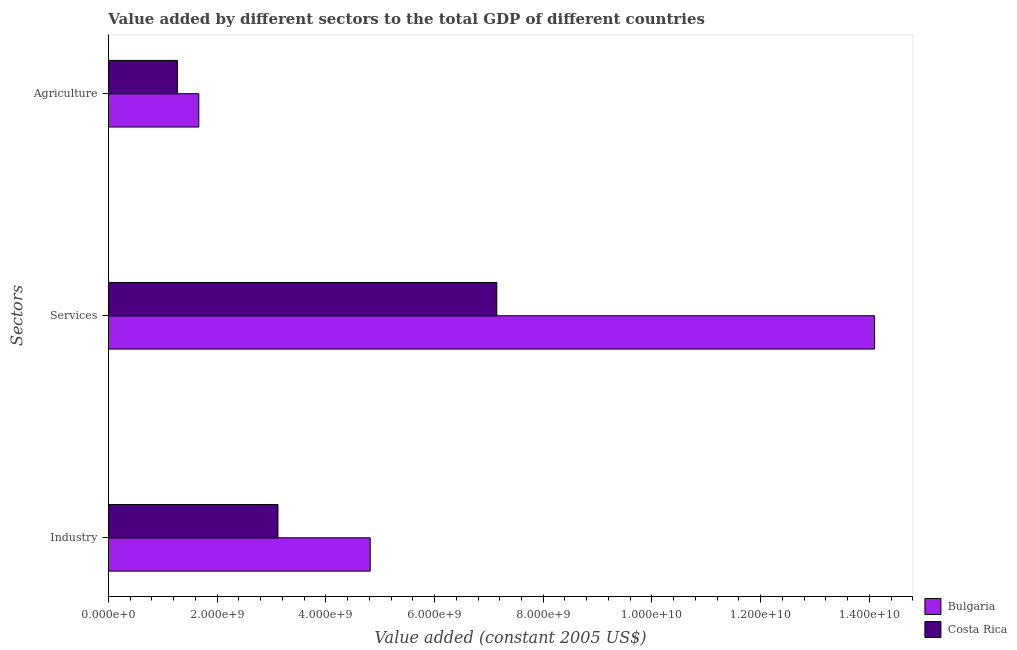How many different coloured bars are there?
Ensure brevity in your answer.  2. How many groups of bars are there?
Offer a very short reply. 3. Are the number of bars on each tick of the Y-axis equal?
Keep it short and to the point. Yes. How many bars are there on the 2nd tick from the top?
Keep it short and to the point. 2. What is the label of the 1st group of bars from the top?
Offer a terse response. Agriculture. What is the value added by agricultural sector in Costa Rica?
Your response must be concise. 1.27e+09. Across all countries, what is the maximum value added by agricultural sector?
Your answer should be compact. 1.66e+09. Across all countries, what is the minimum value added by agricultural sector?
Provide a short and direct response. 1.27e+09. In which country was the value added by services maximum?
Offer a very short reply. Bulgaria. In which country was the value added by services minimum?
Give a very brief answer. Costa Rica. What is the total value added by services in the graph?
Your answer should be compact. 2.12e+1. What is the difference between the value added by industrial sector in Costa Rica and that in Bulgaria?
Your answer should be very brief. -1.70e+09. What is the difference between the value added by services in Costa Rica and the value added by agricultural sector in Bulgaria?
Your answer should be compact. 5.48e+09. What is the average value added by services per country?
Offer a very short reply. 1.06e+1. What is the difference between the value added by industrial sector and value added by services in Costa Rica?
Make the answer very short. -4.03e+09. In how many countries, is the value added by industrial sector greater than 6000000000 US$?
Make the answer very short. 0. What is the ratio of the value added by agricultural sector in Costa Rica to that in Bulgaria?
Give a very brief answer. 0.76. Is the difference between the value added by industrial sector in Bulgaria and Costa Rica greater than the difference between the value added by agricultural sector in Bulgaria and Costa Rica?
Offer a terse response. Yes. What is the difference between the highest and the second highest value added by agricultural sector?
Provide a short and direct response. 3.93e+08. What is the difference between the highest and the lowest value added by services?
Your answer should be very brief. 6.95e+09. In how many countries, is the value added by services greater than the average value added by services taken over all countries?
Make the answer very short. 1. What does the 2nd bar from the top in Services represents?
Keep it short and to the point. Bulgaria. What does the 2nd bar from the bottom in Services represents?
Ensure brevity in your answer.  Costa Rica. Is it the case that in every country, the sum of the value added by industrial sector and value added by services is greater than the value added by agricultural sector?
Make the answer very short. Yes. Are all the bars in the graph horizontal?
Give a very brief answer. Yes. How many countries are there in the graph?
Keep it short and to the point. 2. What is the difference between two consecutive major ticks on the X-axis?
Provide a short and direct response. 2.00e+09. Are the values on the major ticks of X-axis written in scientific E-notation?
Your answer should be very brief. Yes. Does the graph contain any zero values?
Provide a succinct answer. No. How many legend labels are there?
Keep it short and to the point. 2. What is the title of the graph?
Your answer should be very brief. Value added by different sectors to the total GDP of different countries. What is the label or title of the X-axis?
Make the answer very short. Value added (constant 2005 US$). What is the label or title of the Y-axis?
Ensure brevity in your answer.  Sectors. What is the Value added (constant 2005 US$) in Bulgaria in Industry?
Offer a very short reply. 4.82e+09. What is the Value added (constant 2005 US$) of Costa Rica in Industry?
Provide a succinct answer. 3.12e+09. What is the Value added (constant 2005 US$) in Bulgaria in Services?
Ensure brevity in your answer.  1.41e+1. What is the Value added (constant 2005 US$) in Costa Rica in Services?
Your response must be concise. 7.15e+09. What is the Value added (constant 2005 US$) in Bulgaria in Agriculture?
Make the answer very short. 1.66e+09. What is the Value added (constant 2005 US$) in Costa Rica in Agriculture?
Keep it short and to the point. 1.27e+09. Across all Sectors, what is the maximum Value added (constant 2005 US$) of Bulgaria?
Make the answer very short. 1.41e+1. Across all Sectors, what is the maximum Value added (constant 2005 US$) of Costa Rica?
Your answer should be very brief. 7.15e+09. Across all Sectors, what is the minimum Value added (constant 2005 US$) of Bulgaria?
Make the answer very short. 1.66e+09. Across all Sectors, what is the minimum Value added (constant 2005 US$) in Costa Rica?
Give a very brief answer. 1.27e+09. What is the total Value added (constant 2005 US$) of Bulgaria in the graph?
Your answer should be very brief. 2.06e+1. What is the total Value added (constant 2005 US$) in Costa Rica in the graph?
Provide a succinct answer. 1.15e+1. What is the difference between the Value added (constant 2005 US$) in Bulgaria in Industry and that in Services?
Your answer should be compact. -9.28e+09. What is the difference between the Value added (constant 2005 US$) in Costa Rica in Industry and that in Services?
Provide a short and direct response. -4.03e+09. What is the difference between the Value added (constant 2005 US$) of Bulgaria in Industry and that in Agriculture?
Offer a very short reply. 3.15e+09. What is the difference between the Value added (constant 2005 US$) in Costa Rica in Industry and that in Agriculture?
Your answer should be compact. 1.85e+09. What is the difference between the Value added (constant 2005 US$) in Bulgaria in Services and that in Agriculture?
Keep it short and to the point. 1.24e+1. What is the difference between the Value added (constant 2005 US$) of Costa Rica in Services and that in Agriculture?
Provide a succinct answer. 5.88e+09. What is the difference between the Value added (constant 2005 US$) in Bulgaria in Industry and the Value added (constant 2005 US$) in Costa Rica in Services?
Your answer should be compact. -2.33e+09. What is the difference between the Value added (constant 2005 US$) of Bulgaria in Industry and the Value added (constant 2005 US$) of Costa Rica in Agriculture?
Keep it short and to the point. 3.55e+09. What is the difference between the Value added (constant 2005 US$) in Bulgaria in Services and the Value added (constant 2005 US$) in Costa Rica in Agriculture?
Offer a terse response. 1.28e+1. What is the average Value added (constant 2005 US$) in Bulgaria per Sectors?
Give a very brief answer. 6.86e+09. What is the average Value added (constant 2005 US$) of Costa Rica per Sectors?
Your answer should be compact. 3.84e+09. What is the difference between the Value added (constant 2005 US$) of Bulgaria and Value added (constant 2005 US$) of Costa Rica in Industry?
Offer a terse response. 1.70e+09. What is the difference between the Value added (constant 2005 US$) of Bulgaria and Value added (constant 2005 US$) of Costa Rica in Services?
Provide a short and direct response. 6.95e+09. What is the difference between the Value added (constant 2005 US$) of Bulgaria and Value added (constant 2005 US$) of Costa Rica in Agriculture?
Keep it short and to the point. 3.93e+08. What is the ratio of the Value added (constant 2005 US$) of Bulgaria in Industry to that in Services?
Keep it short and to the point. 0.34. What is the ratio of the Value added (constant 2005 US$) of Costa Rica in Industry to that in Services?
Provide a succinct answer. 0.44. What is the ratio of the Value added (constant 2005 US$) in Bulgaria in Industry to that in Agriculture?
Offer a terse response. 2.9. What is the ratio of the Value added (constant 2005 US$) of Costa Rica in Industry to that in Agriculture?
Give a very brief answer. 2.46. What is the ratio of the Value added (constant 2005 US$) in Bulgaria in Services to that in Agriculture?
Offer a terse response. 8.48. What is the ratio of the Value added (constant 2005 US$) of Costa Rica in Services to that in Agriculture?
Your answer should be very brief. 5.63. What is the difference between the highest and the second highest Value added (constant 2005 US$) of Bulgaria?
Your answer should be compact. 9.28e+09. What is the difference between the highest and the second highest Value added (constant 2005 US$) in Costa Rica?
Your answer should be very brief. 4.03e+09. What is the difference between the highest and the lowest Value added (constant 2005 US$) in Bulgaria?
Your answer should be compact. 1.24e+1. What is the difference between the highest and the lowest Value added (constant 2005 US$) of Costa Rica?
Keep it short and to the point. 5.88e+09. 